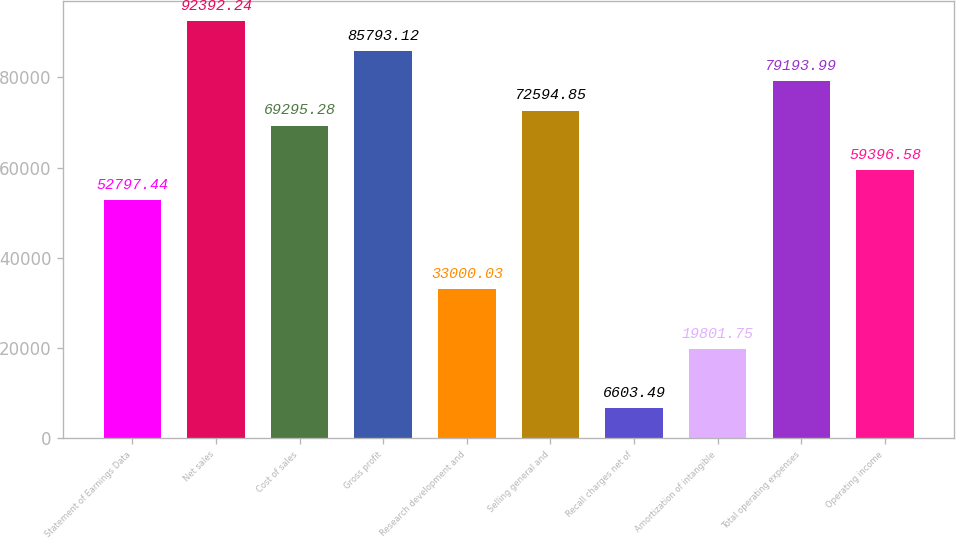Convert chart. <chart><loc_0><loc_0><loc_500><loc_500><bar_chart><fcel>Statement of Earnings Data<fcel>Net sales<fcel>Cost of sales<fcel>Gross profit<fcel>Research development and<fcel>Selling general and<fcel>Recall charges net of<fcel>Amortization of intangible<fcel>Total operating expenses<fcel>Operating income<nl><fcel>52797.4<fcel>92392.2<fcel>69295.3<fcel>85793.1<fcel>33000<fcel>72594.9<fcel>6603.49<fcel>19801.8<fcel>79194<fcel>59396.6<nl></chart> 